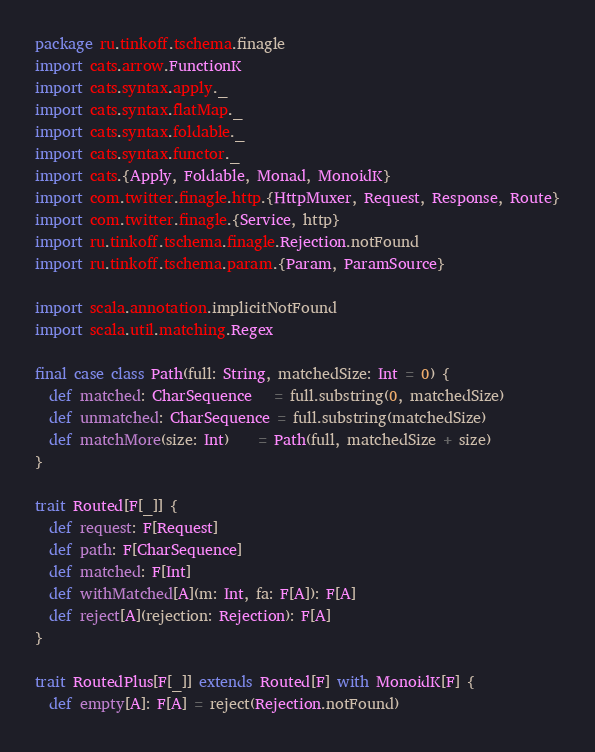Convert code to text. <code><loc_0><loc_0><loc_500><loc_500><_Scala_>package ru.tinkoff.tschema.finagle
import cats.arrow.FunctionK
import cats.syntax.apply._
import cats.syntax.flatMap._
import cats.syntax.foldable._
import cats.syntax.functor._
import cats.{Apply, Foldable, Monad, MonoidK}
import com.twitter.finagle.http.{HttpMuxer, Request, Response, Route}
import com.twitter.finagle.{Service, http}
import ru.tinkoff.tschema.finagle.Rejection.notFound
import ru.tinkoff.tschema.param.{Param, ParamSource}

import scala.annotation.implicitNotFound
import scala.util.matching.Regex

final case class Path(full: String, matchedSize: Int = 0) {
  def matched: CharSequence   = full.substring(0, matchedSize)
  def unmatched: CharSequence = full.substring(matchedSize)
  def matchMore(size: Int)    = Path(full, matchedSize + size)
}

trait Routed[F[_]] {
  def request: F[Request]
  def path: F[CharSequence]
  def matched: F[Int]
  def withMatched[A](m: Int, fa: F[A]): F[A]
  def reject[A](rejection: Rejection): F[A]
}

trait RoutedPlus[F[_]] extends Routed[F] with MonoidK[F] {
  def empty[A]: F[A] = reject(Rejection.notFound)</code> 